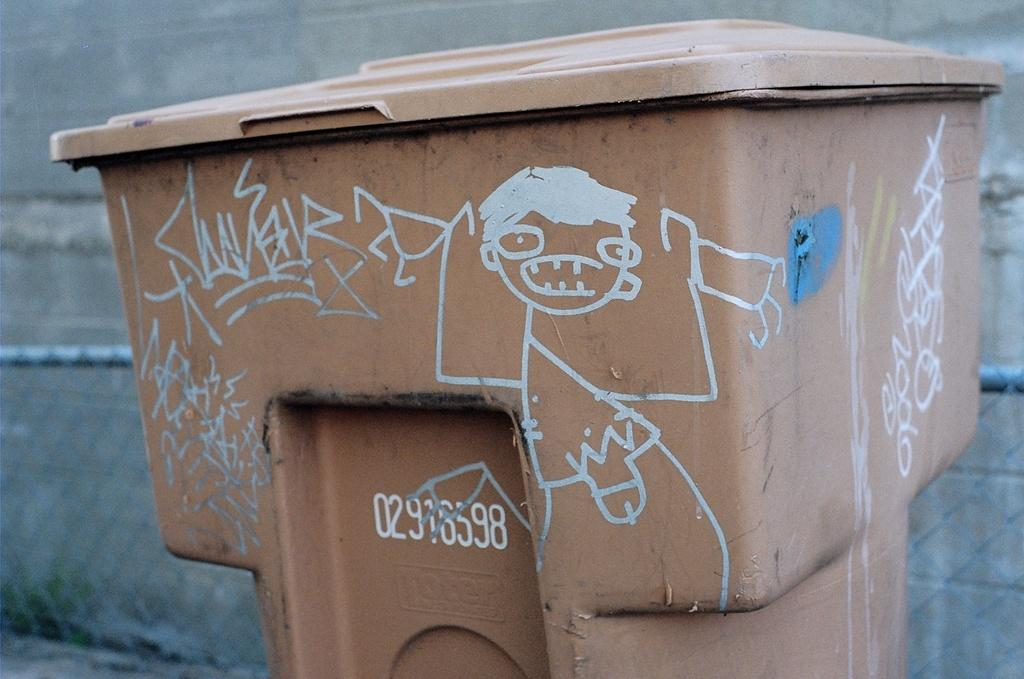Provide a one-sentence caption for the provided image. Brown garbage with numbers which said 02916598 on it. 